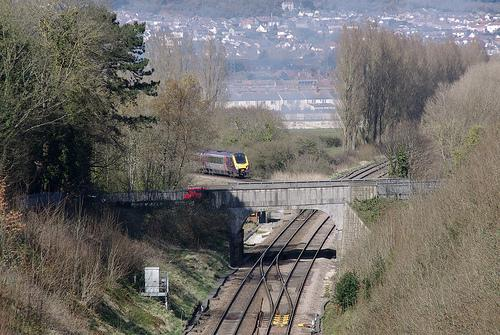Mention one distinguishing feature of the bridge in the image. The bridge in the image is small, concrete and gray in color. What is the color of the train in the picture? The train is red with grey and has a yellow front. Count the number of windows mentioned in the image and describe their locations. There are three types of windows: one on the front of a train, windows on the side of a train, and other unspecified windows. In total, there are at least ten windows. What type of area is shown in the image, and what are the key features present? This is a rural and urban area with train tracks, a bridge, buildings, trees, and tall grass. Identify the primary mode of transportation in the image. The primary mode of transportation in the image is a train on railway tracks. Briefly describe the color and condition of the trees in the picture. The trees in the picture are gray and dead, as well as green in color. What is the sentiment or mood conveyed by the image? The image conveys a mixed sentiment with elements of industrial progress and nature, as well as decay and liveliness. Is there any object in the image that seems out of place or unusual? If so, describe it. There is a silver metal box and a yellow tool on a track, both of which seem unusual in the context of the image. How many sets of railway tracks are present in the image, and what is their characteristic? There are two sets of railway tracks in the image, which are metallic and cross each other. Explain the interaction between the road and railway in the image. The road is above the railway, and there is a car passing on the road near the railway tracks. Can you find any orange trees in the image? No, it's not mentioned in the image. 